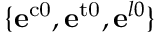<formula> <loc_0><loc_0><loc_500><loc_500>\{ e ^ { c 0 } , e ^ { t 0 } , e ^ { l 0 } \}</formula> 